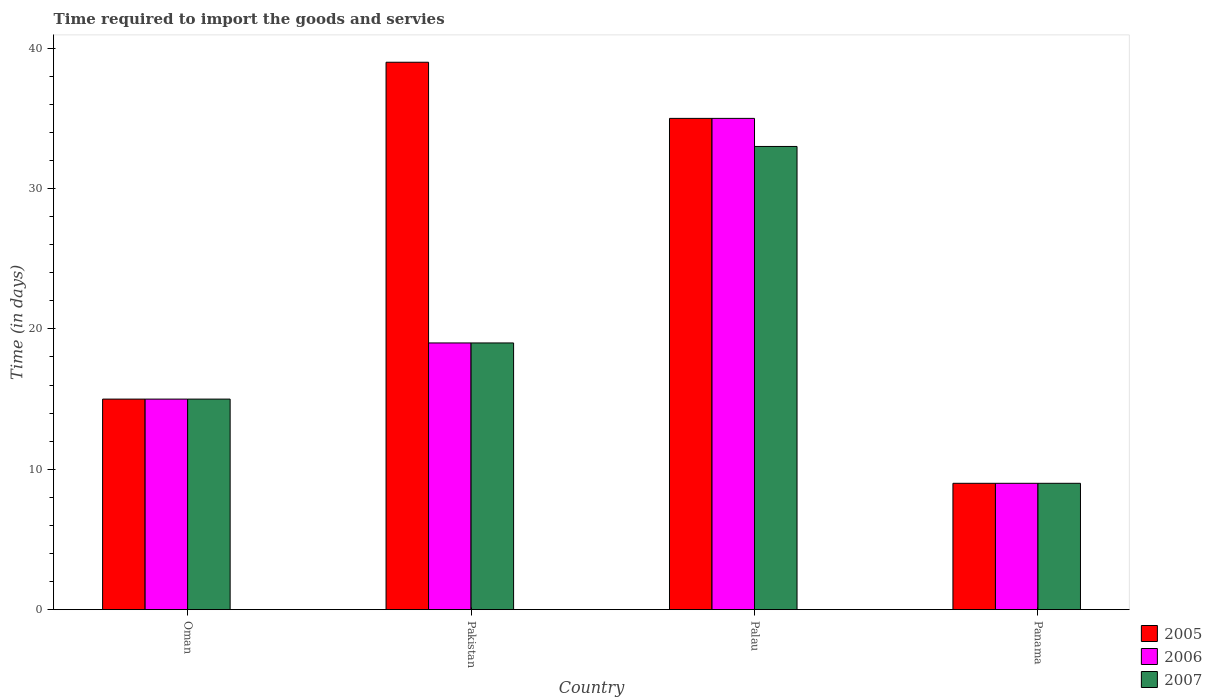How many different coloured bars are there?
Provide a succinct answer. 3. How many bars are there on the 3rd tick from the right?
Offer a very short reply. 3. What is the number of days required to import the goods and services in 2006 in Oman?
Provide a short and direct response. 15. In which country was the number of days required to import the goods and services in 2007 minimum?
Offer a very short reply. Panama. What is the total number of days required to import the goods and services in 2007 in the graph?
Your answer should be compact. 76. What is the difference between the number of days required to import the goods and services in 2005 in Oman and that in Palau?
Provide a short and direct response. -20. What is the difference between the number of days required to import the goods and services in 2006 in Palau and the number of days required to import the goods and services in 2005 in Panama?
Offer a very short reply. 26. What is the average number of days required to import the goods and services in 2006 per country?
Ensure brevity in your answer.  19.5. What is the difference between the number of days required to import the goods and services of/in 2007 and number of days required to import the goods and services of/in 2005 in Palau?
Offer a terse response. -2. What is the ratio of the number of days required to import the goods and services in 2007 in Palau to that in Panama?
Your answer should be compact. 3.67. Is the difference between the number of days required to import the goods and services in 2007 in Pakistan and Palau greater than the difference between the number of days required to import the goods and services in 2005 in Pakistan and Palau?
Your response must be concise. No. How many bars are there?
Your response must be concise. 12. Are all the bars in the graph horizontal?
Your answer should be very brief. No. How many countries are there in the graph?
Provide a short and direct response. 4. What is the difference between two consecutive major ticks on the Y-axis?
Make the answer very short. 10. Does the graph contain any zero values?
Your answer should be very brief. No. Where does the legend appear in the graph?
Give a very brief answer. Bottom right. What is the title of the graph?
Your response must be concise. Time required to import the goods and servies. What is the label or title of the X-axis?
Provide a succinct answer. Country. What is the label or title of the Y-axis?
Your response must be concise. Time (in days). What is the Time (in days) of 2007 in Oman?
Offer a terse response. 15. What is the Time (in days) in 2007 in Pakistan?
Give a very brief answer. 19. What is the Time (in days) of 2005 in Palau?
Your response must be concise. 35. What is the Time (in days) of 2006 in Palau?
Provide a succinct answer. 35. What is the Time (in days) of 2006 in Panama?
Your response must be concise. 9. Across all countries, what is the maximum Time (in days) of 2006?
Offer a very short reply. 35. Across all countries, what is the minimum Time (in days) of 2005?
Keep it short and to the point. 9. What is the total Time (in days) of 2005 in the graph?
Keep it short and to the point. 98. What is the total Time (in days) of 2006 in the graph?
Your response must be concise. 78. What is the total Time (in days) in 2007 in the graph?
Provide a succinct answer. 76. What is the difference between the Time (in days) in 2006 in Oman and that in Pakistan?
Your answer should be compact. -4. What is the difference between the Time (in days) in 2007 in Oman and that in Pakistan?
Offer a very short reply. -4. What is the difference between the Time (in days) of 2005 in Oman and that in Palau?
Give a very brief answer. -20. What is the difference between the Time (in days) in 2007 in Oman and that in Palau?
Make the answer very short. -18. What is the difference between the Time (in days) in 2005 in Oman and that in Panama?
Ensure brevity in your answer.  6. What is the difference between the Time (in days) of 2005 in Pakistan and that in Palau?
Your answer should be very brief. 4. What is the difference between the Time (in days) of 2005 in Pakistan and that in Panama?
Your answer should be compact. 30. What is the difference between the Time (in days) in 2006 in Pakistan and that in Panama?
Offer a very short reply. 10. What is the difference between the Time (in days) of 2007 in Pakistan and that in Panama?
Your answer should be very brief. 10. What is the difference between the Time (in days) in 2007 in Palau and that in Panama?
Your answer should be compact. 24. What is the difference between the Time (in days) of 2006 in Oman and the Time (in days) of 2007 in Pakistan?
Give a very brief answer. -4. What is the difference between the Time (in days) in 2005 in Oman and the Time (in days) in 2006 in Palau?
Offer a very short reply. -20. What is the difference between the Time (in days) in 2006 in Oman and the Time (in days) in 2007 in Panama?
Give a very brief answer. 6. What is the difference between the Time (in days) of 2005 in Pakistan and the Time (in days) of 2006 in Palau?
Ensure brevity in your answer.  4. What is the difference between the Time (in days) of 2005 in Pakistan and the Time (in days) of 2007 in Palau?
Offer a very short reply. 6. What is the difference between the Time (in days) in 2005 in Pakistan and the Time (in days) in 2007 in Panama?
Offer a terse response. 30. What is the difference between the Time (in days) of 2006 in Pakistan and the Time (in days) of 2007 in Panama?
Ensure brevity in your answer.  10. What is the difference between the Time (in days) of 2005 in Palau and the Time (in days) of 2006 in Panama?
Provide a short and direct response. 26. What is the difference between the Time (in days) in 2005 in Palau and the Time (in days) in 2007 in Panama?
Provide a succinct answer. 26. What is the difference between the Time (in days) of 2006 in Palau and the Time (in days) of 2007 in Panama?
Make the answer very short. 26. What is the average Time (in days) of 2005 per country?
Ensure brevity in your answer.  24.5. What is the average Time (in days) of 2006 per country?
Give a very brief answer. 19.5. What is the average Time (in days) in 2007 per country?
Your answer should be compact. 19. What is the difference between the Time (in days) in 2006 and Time (in days) in 2007 in Oman?
Offer a terse response. 0. What is the difference between the Time (in days) of 2005 and Time (in days) of 2006 in Pakistan?
Provide a short and direct response. 20. What is the difference between the Time (in days) of 2006 and Time (in days) of 2007 in Pakistan?
Make the answer very short. 0. What is the difference between the Time (in days) in 2005 and Time (in days) in 2007 in Palau?
Make the answer very short. 2. What is the difference between the Time (in days) in 2005 and Time (in days) in 2006 in Panama?
Provide a short and direct response. 0. What is the difference between the Time (in days) of 2006 and Time (in days) of 2007 in Panama?
Your answer should be compact. 0. What is the ratio of the Time (in days) in 2005 in Oman to that in Pakistan?
Offer a very short reply. 0.38. What is the ratio of the Time (in days) in 2006 in Oman to that in Pakistan?
Offer a very short reply. 0.79. What is the ratio of the Time (in days) of 2007 in Oman to that in Pakistan?
Provide a short and direct response. 0.79. What is the ratio of the Time (in days) of 2005 in Oman to that in Palau?
Make the answer very short. 0.43. What is the ratio of the Time (in days) in 2006 in Oman to that in Palau?
Offer a terse response. 0.43. What is the ratio of the Time (in days) in 2007 in Oman to that in Palau?
Offer a very short reply. 0.45. What is the ratio of the Time (in days) in 2005 in Pakistan to that in Palau?
Keep it short and to the point. 1.11. What is the ratio of the Time (in days) of 2006 in Pakistan to that in Palau?
Make the answer very short. 0.54. What is the ratio of the Time (in days) in 2007 in Pakistan to that in Palau?
Give a very brief answer. 0.58. What is the ratio of the Time (in days) in 2005 in Pakistan to that in Panama?
Ensure brevity in your answer.  4.33. What is the ratio of the Time (in days) of 2006 in Pakistan to that in Panama?
Your answer should be compact. 2.11. What is the ratio of the Time (in days) of 2007 in Pakistan to that in Panama?
Offer a terse response. 2.11. What is the ratio of the Time (in days) in 2005 in Palau to that in Panama?
Your answer should be compact. 3.89. What is the ratio of the Time (in days) in 2006 in Palau to that in Panama?
Provide a short and direct response. 3.89. What is the ratio of the Time (in days) of 2007 in Palau to that in Panama?
Your answer should be compact. 3.67. What is the difference between the highest and the second highest Time (in days) of 2005?
Make the answer very short. 4. What is the difference between the highest and the lowest Time (in days) in 2006?
Give a very brief answer. 26. 